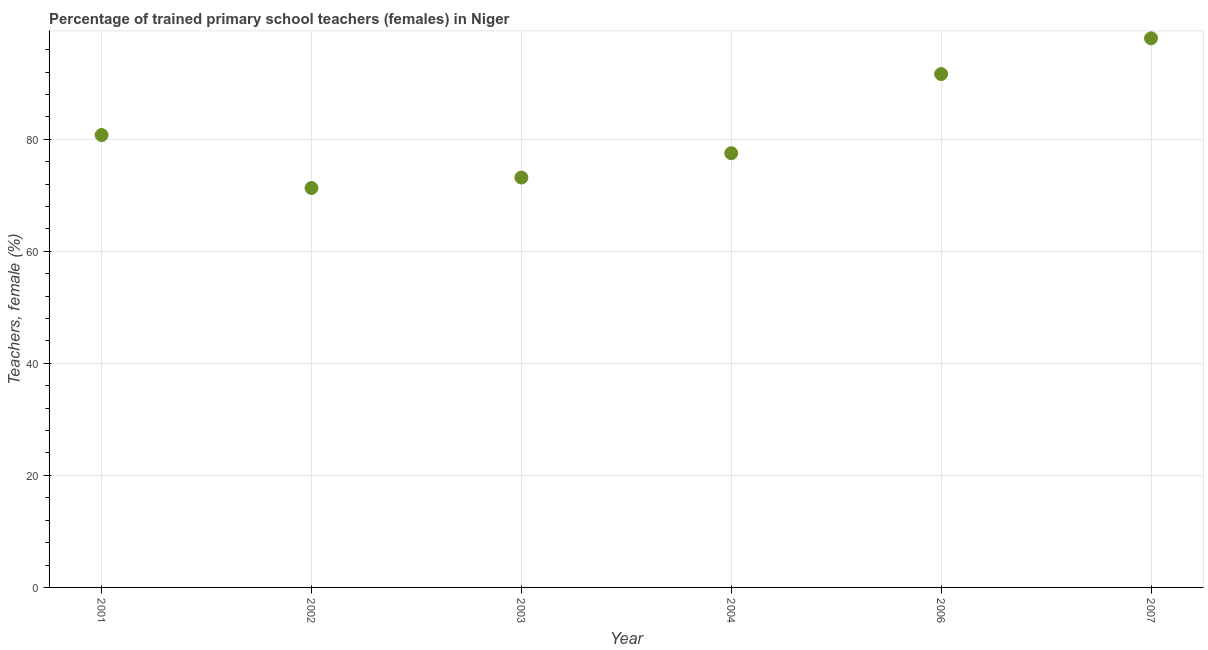What is the percentage of trained female teachers in 2006?
Your response must be concise. 91.63. Across all years, what is the maximum percentage of trained female teachers?
Provide a short and direct response. 98.02. Across all years, what is the minimum percentage of trained female teachers?
Ensure brevity in your answer.  71.3. What is the sum of the percentage of trained female teachers?
Provide a succinct answer. 492.38. What is the difference between the percentage of trained female teachers in 2006 and 2007?
Make the answer very short. -6.38. What is the average percentage of trained female teachers per year?
Your answer should be compact. 82.06. What is the median percentage of trained female teachers?
Offer a very short reply. 79.13. In how many years, is the percentage of trained female teachers greater than 24 %?
Make the answer very short. 6. Do a majority of the years between 2004 and 2001 (inclusive) have percentage of trained female teachers greater than 52 %?
Your response must be concise. Yes. What is the ratio of the percentage of trained female teachers in 2001 to that in 2006?
Offer a very short reply. 0.88. Is the percentage of trained female teachers in 2003 less than that in 2006?
Your response must be concise. Yes. What is the difference between the highest and the second highest percentage of trained female teachers?
Offer a terse response. 6.38. Is the sum of the percentage of trained female teachers in 2004 and 2006 greater than the maximum percentage of trained female teachers across all years?
Offer a terse response. Yes. What is the difference between the highest and the lowest percentage of trained female teachers?
Provide a succinct answer. 26.72. How many dotlines are there?
Provide a short and direct response. 1. How many years are there in the graph?
Give a very brief answer. 6. What is the difference between two consecutive major ticks on the Y-axis?
Make the answer very short. 20. Are the values on the major ticks of Y-axis written in scientific E-notation?
Offer a very short reply. No. What is the title of the graph?
Give a very brief answer. Percentage of trained primary school teachers (females) in Niger. What is the label or title of the Y-axis?
Your answer should be compact. Teachers, female (%). What is the Teachers, female (%) in 2001?
Ensure brevity in your answer.  80.75. What is the Teachers, female (%) in 2002?
Ensure brevity in your answer.  71.3. What is the Teachers, female (%) in 2003?
Give a very brief answer. 73.16. What is the Teachers, female (%) in 2004?
Provide a short and direct response. 77.51. What is the Teachers, female (%) in 2006?
Make the answer very short. 91.63. What is the Teachers, female (%) in 2007?
Ensure brevity in your answer.  98.02. What is the difference between the Teachers, female (%) in 2001 and 2002?
Provide a succinct answer. 9.45. What is the difference between the Teachers, female (%) in 2001 and 2003?
Your answer should be compact. 7.59. What is the difference between the Teachers, female (%) in 2001 and 2004?
Offer a terse response. 3.24. What is the difference between the Teachers, female (%) in 2001 and 2006?
Provide a short and direct response. -10.88. What is the difference between the Teachers, female (%) in 2001 and 2007?
Your answer should be very brief. -17.27. What is the difference between the Teachers, female (%) in 2002 and 2003?
Provide a short and direct response. -1.87. What is the difference between the Teachers, female (%) in 2002 and 2004?
Give a very brief answer. -6.21. What is the difference between the Teachers, female (%) in 2002 and 2006?
Give a very brief answer. -20.34. What is the difference between the Teachers, female (%) in 2002 and 2007?
Your response must be concise. -26.72. What is the difference between the Teachers, female (%) in 2003 and 2004?
Your answer should be compact. -4.35. What is the difference between the Teachers, female (%) in 2003 and 2006?
Make the answer very short. -18.47. What is the difference between the Teachers, female (%) in 2003 and 2007?
Keep it short and to the point. -24.85. What is the difference between the Teachers, female (%) in 2004 and 2006?
Your answer should be very brief. -14.12. What is the difference between the Teachers, female (%) in 2004 and 2007?
Ensure brevity in your answer.  -20.51. What is the difference between the Teachers, female (%) in 2006 and 2007?
Provide a short and direct response. -6.38. What is the ratio of the Teachers, female (%) in 2001 to that in 2002?
Keep it short and to the point. 1.13. What is the ratio of the Teachers, female (%) in 2001 to that in 2003?
Offer a very short reply. 1.1. What is the ratio of the Teachers, female (%) in 2001 to that in 2004?
Give a very brief answer. 1.04. What is the ratio of the Teachers, female (%) in 2001 to that in 2006?
Make the answer very short. 0.88. What is the ratio of the Teachers, female (%) in 2001 to that in 2007?
Offer a very short reply. 0.82. What is the ratio of the Teachers, female (%) in 2002 to that in 2003?
Provide a succinct answer. 0.97. What is the ratio of the Teachers, female (%) in 2002 to that in 2004?
Provide a succinct answer. 0.92. What is the ratio of the Teachers, female (%) in 2002 to that in 2006?
Your answer should be very brief. 0.78. What is the ratio of the Teachers, female (%) in 2002 to that in 2007?
Keep it short and to the point. 0.73. What is the ratio of the Teachers, female (%) in 2003 to that in 2004?
Offer a very short reply. 0.94. What is the ratio of the Teachers, female (%) in 2003 to that in 2006?
Your answer should be very brief. 0.8. What is the ratio of the Teachers, female (%) in 2003 to that in 2007?
Provide a short and direct response. 0.75. What is the ratio of the Teachers, female (%) in 2004 to that in 2006?
Offer a very short reply. 0.85. What is the ratio of the Teachers, female (%) in 2004 to that in 2007?
Make the answer very short. 0.79. What is the ratio of the Teachers, female (%) in 2006 to that in 2007?
Provide a short and direct response. 0.94. 